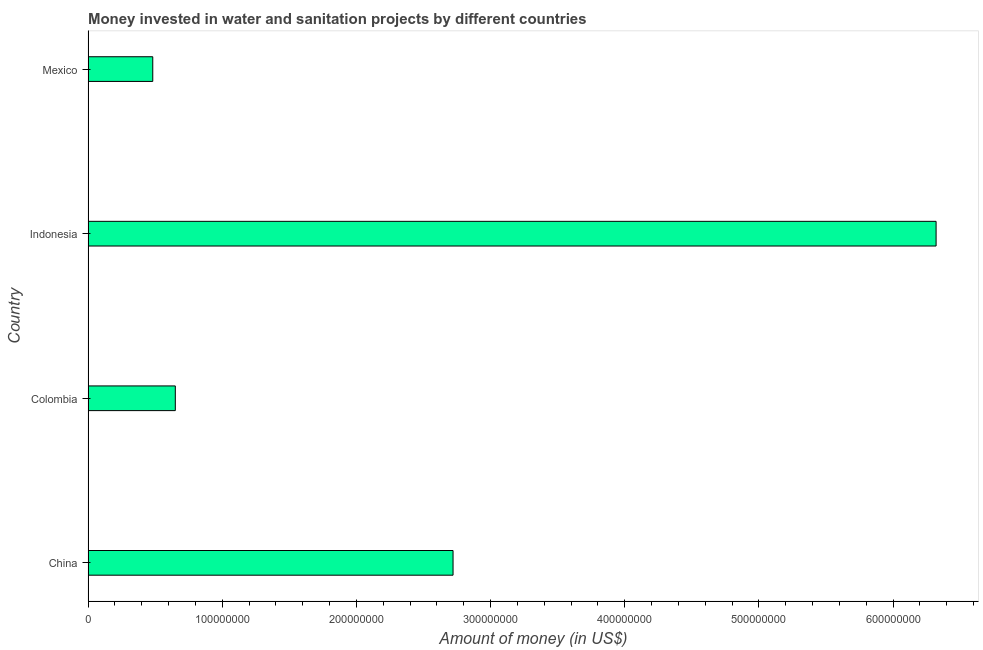Does the graph contain grids?
Your response must be concise. No. What is the title of the graph?
Your answer should be very brief. Money invested in water and sanitation projects by different countries. What is the label or title of the X-axis?
Keep it short and to the point. Amount of money (in US$). What is the investment in Colombia?
Your answer should be compact. 6.50e+07. Across all countries, what is the maximum investment?
Your answer should be very brief. 6.32e+08. Across all countries, what is the minimum investment?
Keep it short and to the point. 4.82e+07. In which country was the investment maximum?
Ensure brevity in your answer.  Indonesia. What is the sum of the investment?
Your response must be concise. 1.02e+09. What is the difference between the investment in Colombia and Indonesia?
Ensure brevity in your answer.  -5.67e+08. What is the average investment per country?
Provide a short and direct response. 2.54e+08. What is the median investment?
Your answer should be very brief. 1.68e+08. In how many countries, is the investment greater than 480000000 US$?
Offer a terse response. 1. What is the ratio of the investment in Colombia to that in Indonesia?
Ensure brevity in your answer.  0.1. What is the difference between the highest and the second highest investment?
Make the answer very short. 3.60e+08. What is the difference between the highest and the lowest investment?
Keep it short and to the point. 5.84e+08. Are all the bars in the graph horizontal?
Provide a short and direct response. Yes. What is the difference between two consecutive major ticks on the X-axis?
Offer a very short reply. 1.00e+08. What is the Amount of money (in US$) in China?
Give a very brief answer. 2.72e+08. What is the Amount of money (in US$) in Colombia?
Offer a terse response. 6.50e+07. What is the Amount of money (in US$) in Indonesia?
Give a very brief answer. 6.32e+08. What is the Amount of money (in US$) in Mexico?
Offer a terse response. 4.82e+07. What is the difference between the Amount of money (in US$) in China and Colombia?
Offer a terse response. 2.07e+08. What is the difference between the Amount of money (in US$) in China and Indonesia?
Offer a terse response. -3.60e+08. What is the difference between the Amount of money (in US$) in China and Mexico?
Your response must be concise. 2.24e+08. What is the difference between the Amount of money (in US$) in Colombia and Indonesia?
Ensure brevity in your answer.  -5.67e+08. What is the difference between the Amount of money (in US$) in Colombia and Mexico?
Give a very brief answer. 1.68e+07. What is the difference between the Amount of money (in US$) in Indonesia and Mexico?
Make the answer very short. 5.84e+08. What is the ratio of the Amount of money (in US$) in China to that in Colombia?
Keep it short and to the point. 4.18. What is the ratio of the Amount of money (in US$) in China to that in Indonesia?
Your response must be concise. 0.43. What is the ratio of the Amount of money (in US$) in China to that in Mexico?
Offer a terse response. 5.64. What is the ratio of the Amount of money (in US$) in Colombia to that in Indonesia?
Make the answer very short. 0.1. What is the ratio of the Amount of money (in US$) in Colombia to that in Mexico?
Your answer should be very brief. 1.35. What is the ratio of the Amount of money (in US$) in Indonesia to that in Mexico?
Your answer should be compact. 13.11. 